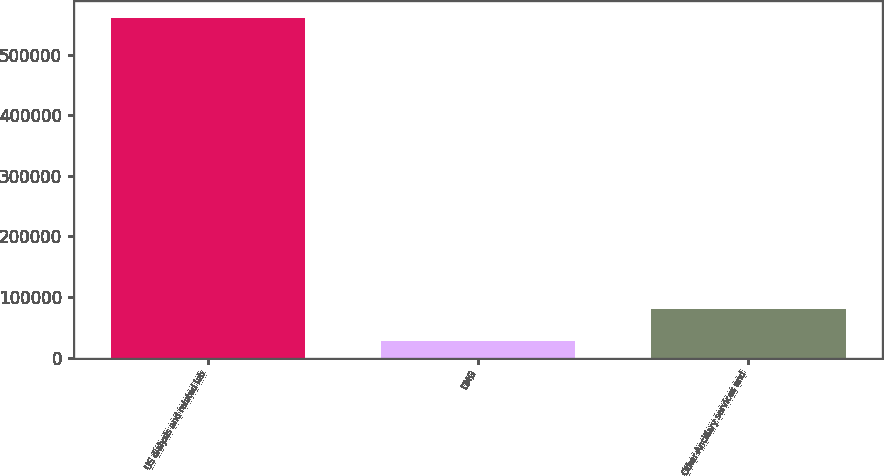Convert chart to OTSL. <chart><loc_0><loc_0><loc_500><loc_500><bar_chart><fcel>US dialysis and related lab<fcel>DMG<fcel>Other-Ancillary services and<nl><fcel>560610<fcel>27885<fcel>81157.5<nl></chart> 